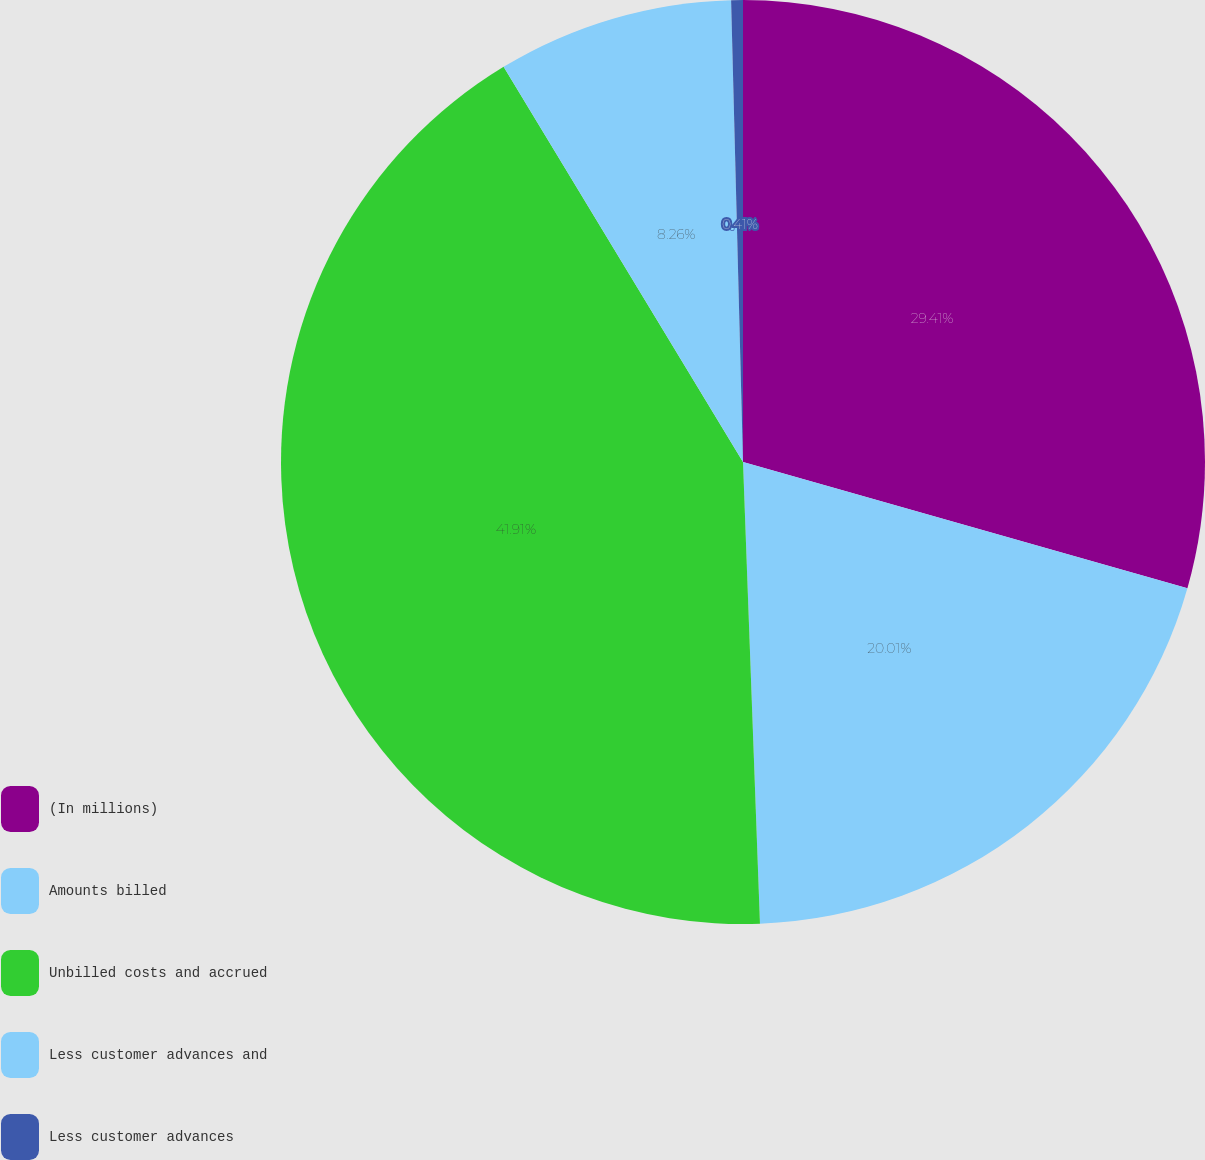Convert chart to OTSL. <chart><loc_0><loc_0><loc_500><loc_500><pie_chart><fcel>(In millions)<fcel>Amounts billed<fcel>Unbilled costs and accrued<fcel>Less customer advances and<fcel>Less customer advances<nl><fcel>29.41%<fcel>20.01%<fcel>41.92%<fcel>8.26%<fcel>0.41%<nl></chart> 